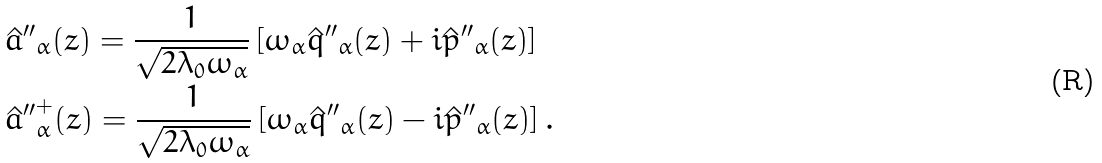<formula> <loc_0><loc_0><loc_500><loc_500>& \hat { a } { ^ { \prime \prime } } _ { \alpha } ( z ) = \frac { 1 } { \sqrt { 2 \lambda _ { 0 } \omega _ { \alpha } } } \left [ \omega _ { \alpha } \hat { q } { ^ { \prime \prime } } _ { \alpha } ( z ) + i \hat { p } { ^ { \prime \prime } } _ { \alpha } ( z ) \right ] \\ & \hat { a } { ^ { \prime \prime } } ^ { + } _ { \alpha } ( z ) = \frac { 1 } { \sqrt { 2 \lambda _ { 0 } \omega _ { \alpha } } } \left [ \omega _ { \alpha } \hat { q } { ^ { \prime \prime } } _ { \alpha } ( z ) - i \hat { p } { ^ { \prime \prime } } _ { \alpha } ( z ) \right ] .</formula> 